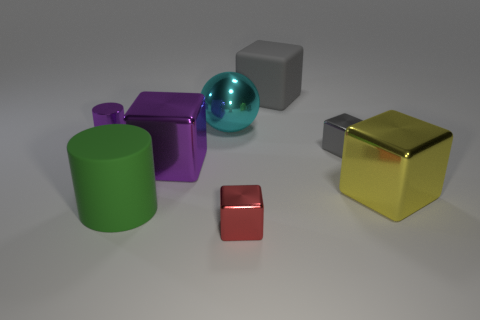There is a gray matte object; what shape is it? The gray matte object in the image is an exact cube, with each of its six faces being perfectly square and of equal size. 